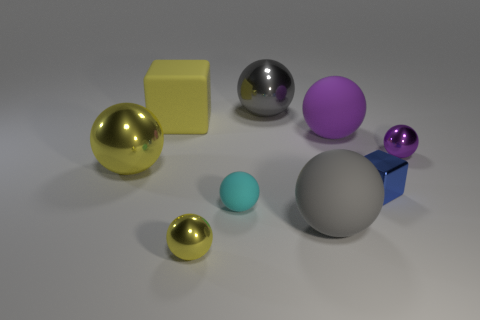What shape is the small yellow thing that is made of the same material as the tiny block?
Give a very brief answer. Sphere. There is a large thing to the right of the large ball in front of the blue shiny block; what is its color?
Keep it short and to the point. Purple. Is the small metallic cube the same color as the tiny rubber thing?
Offer a terse response. No. The big ball in front of the cube that is on the right side of the tiny cyan sphere is made of what material?
Your response must be concise. Rubber. There is a cyan object that is the same shape as the purple matte object; what is its material?
Your answer should be very brief. Rubber. There is a blue cube that is in front of the large rubber object to the left of the gray shiny thing; are there any large gray metallic balls that are in front of it?
Your response must be concise. No. What number of other things are there of the same color as the big block?
Give a very brief answer. 2. How many things are both in front of the tiny purple object and left of the gray rubber thing?
Provide a short and direct response. 3. What is the shape of the purple shiny thing?
Offer a terse response. Sphere. How many other things are there of the same material as the small cyan object?
Provide a short and direct response. 3. 